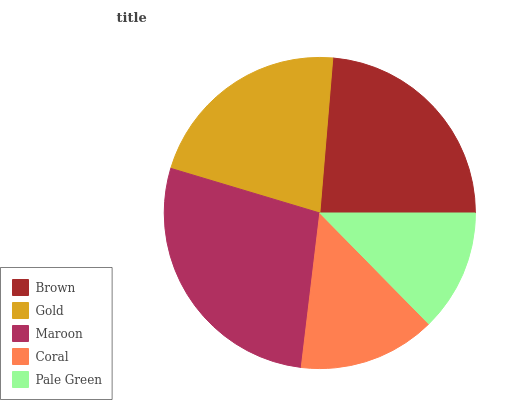Is Pale Green the minimum?
Answer yes or no. Yes. Is Maroon the maximum?
Answer yes or no. Yes. Is Gold the minimum?
Answer yes or no. No. Is Gold the maximum?
Answer yes or no. No. Is Brown greater than Gold?
Answer yes or no. Yes. Is Gold less than Brown?
Answer yes or no. Yes. Is Gold greater than Brown?
Answer yes or no. No. Is Brown less than Gold?
Answer yes or no. No. Is Gold the high median?
Answer yes or no. Yes. Is Gold the low median?
Answer yes or no. Yes. Is Maroon the high median?
Answer yes or no. No. Is Coral the low median?
Answer yes or no. No. 